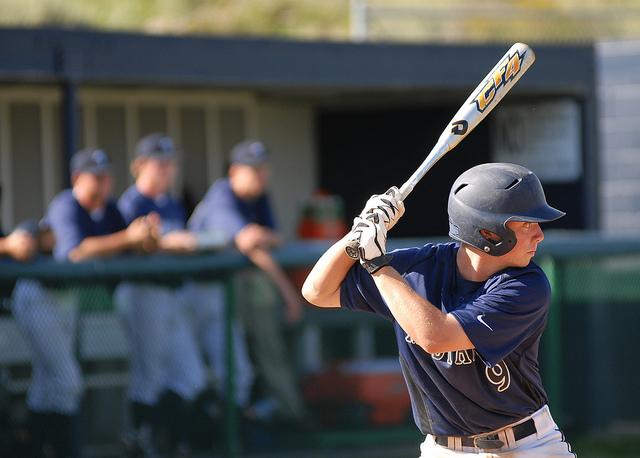How many players are in the picture?
Be succinct. 4. What position does the player who will throw the ball towards the batter play?
Write a very short answer. Pitcher. Is the player right-handed?
Quick response, please. Yes. 